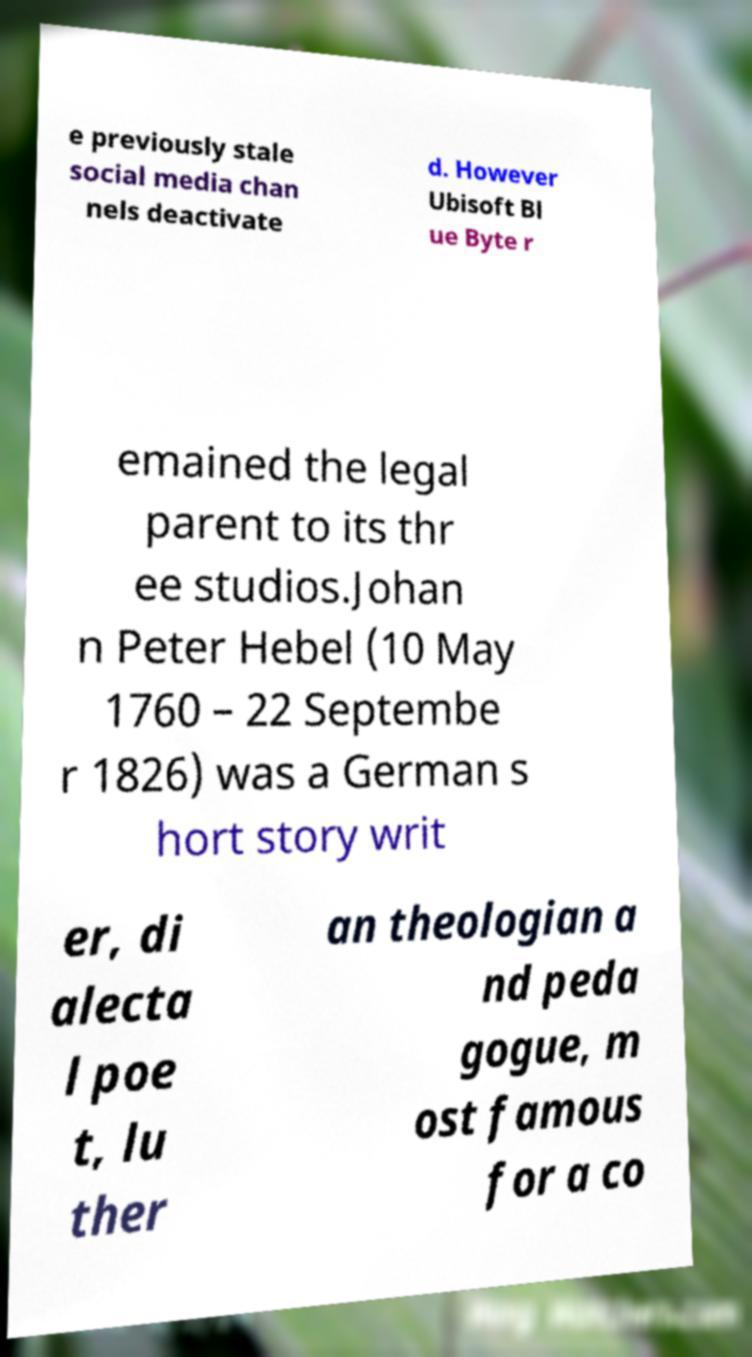There's text embedded in this image that I need extracted. Can you transcribe it verbatim? e previously stale social media chan nels deactivate d. However Ubisoft Bl ue Byte r emained the legal parent to its thr ee studios.Johan n Peter Hebel (10 May 1760 – 22 Septembe r 1826) was a German s hort story writ er, di alecta l poe t, lu ther an theologian a nd peda gogue, m ost famous for a co 